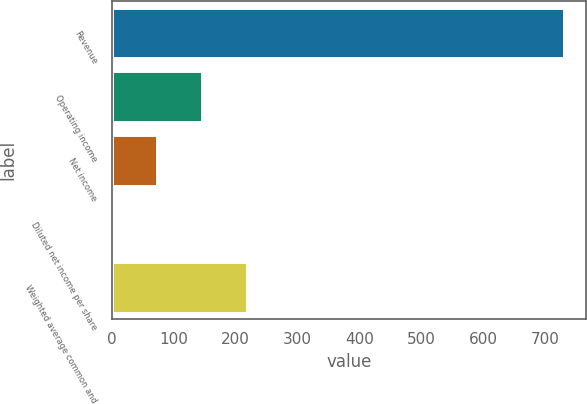<chart> <loc_0><loc_0><loc_500><loc_500><bar_chart><fcel>Revenue<fcel>Operating income<fcel>Net income<fcel>Diluted net income per share<fcel>Weighted average common and<nl><fcel>730<fcel>146.37<fcel>73.41<fcel>0.45<fcel>219.32<nl></chart> 